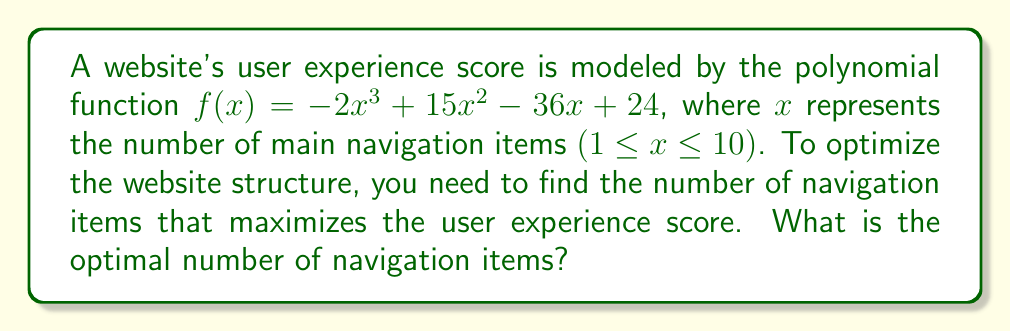Solve this math problem. To find the optimal number of navigation items, we need to find the maximum value of the function $f(x)$ within the given domain.

1. Find the derivative of $f(x)$:
   $f'(x) = -6x^2 + 30x - 36$

2. Set $f'(x) = 0$ to find critical points:
   $-6x^2 + 30x - 36 = 0$

3. Solve the quadratic equation:
   $-6(x^2 - 5x + 6) = 0$
   $-6(x - 2)(x - 3) = 0$
   $x = 2$ or $x = 3$

4. Check the endpoints of the domain (1 and 10):
   $f(1) = -2(1)^3 + 15(1)^2 - 36(1) + 24 = 1$
   $f(10) = -2(10)^3 + 15(10)^2 - 36(10) + 24 = -1976$

5. Evaluate $f(x)$ at the critical points:
   $f(2) = -2(2)^3 + 15(2)^2 - 36(2) + 24 = 28$
   $f(3) = -2(3)^3 + 15(3)^2 - 36(3) + 24 = 33$

6. Compare the values:
   $f(1) = 1$
   $f(2) = 28$
   $f(3) = 33$
   $f(10) = -1976$

The maximum value occurs at $x = 3$, which is within the given domain.
Answer: 3 